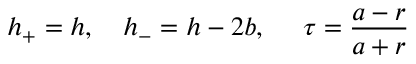<formula> <loc_0><loc_0><loc_500><loc_500>h _ { + } = h , \quad h _ { - } = h - 2 b , \quad \tau = \frac { a - r } { a + r }</formula> 